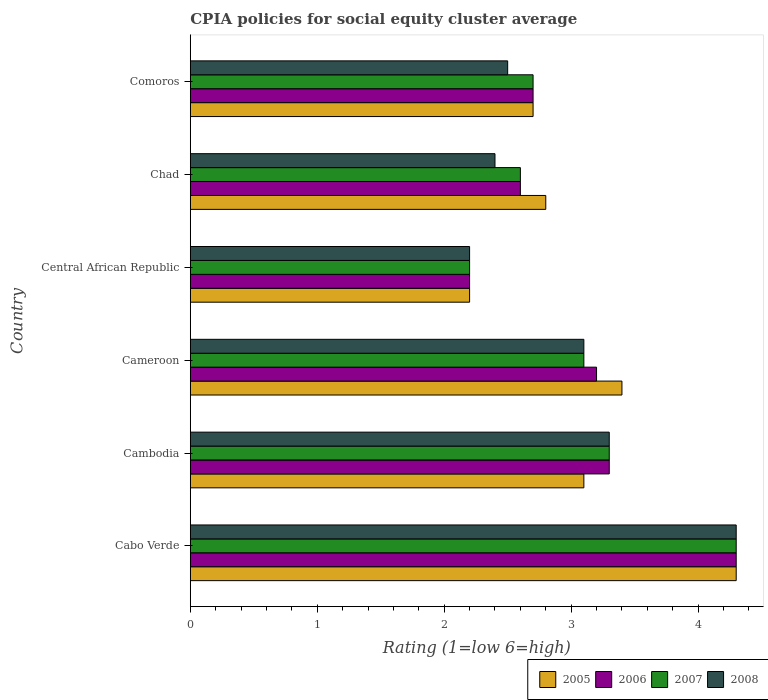Are the number of bars per tick equal to the number of legend labels?
Your response must be concise. Yes. How many bars are there on the 4th tick from the top?
Make the answer very short. 4. How many bars are there on the 3rd tick from the bottom?
Offer a very short reply. 4. What is the label of the 2nd group of bars from the top?
Ensure brevity in your answer.  Chad. Across all countries, what is the maximum CPIA rating in 2006?
Provide a short and direct response. 4.3. Across all countries, what is the minimum CPIA rating in 2008?
Make the answer very short. 2.2. In which country was the CPIA rating in 2008 maximum?
Provide a succinct answer. Cabo Verde. In which country was the CPIA rating in 2006 minimum?
Provide a succinct answer. Central African Republic. What is the difference between the CPIA rating in 2005 in Cambodia and that in Comoros?
Your answer should be very brief. 0.4. What is the difference between the CPIA rating in 2007 in Cambodia and the CPIA rating in 2005 in Central African Republic?
Make the answer very short. 1.1. What is the average CPIA rating in 2006 per country?
Your answer should be compact. 3.05. What is the ratio of the CPIA rating in 2008 in Cambodia to that in Comoros?
Provide a short and direct response. 1.32. Is the CPIA rating in 2005 in Cabo Verde less than that in Central African Republic?
Your answer should be very brief. No. Is the difference between the CPIA rating in 2008 in Cambodia and Central African Republic greater than the difference between the CPIA rating in 2007 in Cambodia and Central African Republic?
Your answer should be very brief. No. What is the difference between the highest and the second highest CPIA rating in 2005?
Make the answer very short. 0.9. What is the difference between the highest and the lowest CPIA rating in 2005?
Make the answer very short. 2.1. In how many countries, is the CPIA rating in 2008 greater than the average CPIA rating in 2008 taken over all countries?
Give a very brief answer. 3. Is the sum of the CPIA rating in 2007 in Central African Republic and Chad greater than the maximum CPIA rating in 2006 across all countries?
Your response must be concise. Yes. What does the 4th bar from the top in Cabo Verde represents?
Offer a very short reply. 2005. What does the 2nd bar from the bottom in Cambodia represents?
Provide a succinct answer. 2006. How many countries are there in the graph?
Make the answer very short. 6. Are the values on the major ticks of X-axis written in scientific E-notation?
Offer a very short reply. No. Does the graph contain any zero values?
Ensure brevity in your answer.  No. Does the graph contain grids?
Offer a very short reply. No. How many legend labels are there?
Ensure brevity in your answer.  4. How are the legend labels stacked?
Offer a very short reply. Horizontal. What is the title of the graph?
Your answer should be very brief. CPIA policies for social equity cluster average. What is the label or title of the X-axis?
Your answer should be very brief. Rating (1=low 6=high). What is the label or title of the Y-axis?
Your response must be concise. Country. What is the Rating (1=low 6=high) in 2005 in Cabo Verde?
Ensure brevity in your answer.  4.3. What is the Rating (1=low 6=high) of 2006 in Cabo Verde?
Give a very brief answer. 4.3. What is the Rating (1=low 6=high) in 2007 in Cambodia?
Provide a short and direct response. 3.3. What is the Rating (1=low 6=high) of 2008 in Cambodia?
Your answer should be very brief. 3.3. What is the Rating (1=low 6=high) of 2008 in Cameroon?
Your answer should be very brief. 3.1. What is the Rating (1=low 6=high) in 2008 in Central African Republic?
Ensure brevity in your answer.  2.2. What is the Rating (1=low 6=high) of 2005 in Chad?
Provide a succinct answer. 2.8. What is the Rating (1=low 6=high) of 2006 in Chad?
Your answer should be very brief. 2.6. What is the Rating (1=low 6=high) of 2007 in Chad?
Your answer should be compact. 2.6. What is the Rating (1=low 6=high) in 2008 in Chad?
Make the answer very short. 2.4. What is the Rating (1=low 6=high) of 2006 in Comoros?
Ensure brevity in your answer.  2.7. What is the Rating (1=low 6=high) in 2008 in Comoros?
Your answer should be very brief. 2.5. Across all countries, what is the maximum Rating (1=low 6=high) in 2006?
Make the answer very short. 4.3. Across all countries, what is the maximum Rating (1=low 6=high) in 2007?
Offer a very short reply. 4.3. Across all countries, what is the maximum Rating (1=low 6=high) in 2008?
Your answer should be very brief. 4.3. Across all countries, what is the minimum Rating (1=low 6=high) in 2006?
Your response must be concise. 2.2. Across all countries, what is the minimum Rating (1=low 6=high) in 2007?
Ensure brevity in your answer.  2.2. What is the total Rating (1=low 6=high) of 2005 in the graph?
Your response must be concise. 18.5. What is the difference between the Rating (1=low 6=high) of 2005 in Cabo Verde and that in Cambodia?
Provide a succinct answer. 1.2. What is the difference between the Rating (1=low 6=high) in 2006 in Cabo Verde and that in Cambodia?
Make the answer very short. 1. What is the difference between the Rating (1=low 6=high) in 2007 in Cabo Verde and that in Cambodia?
Your answer should be very brief. 1. What is the difference between the Rating (1=low 6=high) in 2007 in Cabo Verde and that in Cameroon?
Make the answer very short. 1.2. What is the difference between the Rating (1=low 6=high) in 2005 in Cabo Verde and that in Central African Republic?
Ensure brevity in your answer.  2.1. What is the difference between the Rating (1=low 6=high) of 2006 in Cabo Verde and that in Central African Republic?
Provide a succinct answer. 2.1. What is the difference between the Rating (1=low 6=high) of 2007 in Cabo Verde and that in Central African Republic?
Keep it short and to the point. 2.1. What is the difference between the Rating (1=low 6=high) of 2007 in Cabo Verde and that in Chad?
Offer a very short reply. 1.7. What is the difference between the Rating (1=low 6=high) of 2005 in Cabo Verde and that in Comoros?
Give a very brief answer. 1.6. What is the difference between the Rating (1=low 6=high) in 2007 in Cabo Verde and that in Comoros?
Provide a short and direct response. 1.6. What is the difference between the Rating (1=low 6=high) of 2008 in Cabo Verde and that in Comoros?
Ensure brevity in your answer.  1.8. What is the difference between the Rating (1=low 6=high) of 2006 in Cambodia and that in Cameroon?
Your answer should be compact. 0.1. What is the difference between the Rating (1=low 6=high) of 2006 in Cambodia and that in Central African Republic?
Provide a short and direct response. 1.1. What is the difference between the Rating (1=low 6=high) in 2007 in Cambodia and that in Central African Republic?
Keep it short and to the point. 1.1. What is the difference between the Rating (1=low 6=high) of 2008 in Cambodia and that in Central African Republic?
Your answer should be compact. 1.1. What is the difference between the Rating (1=low 6=high) in 2006 in Cambodia and that in Chad?
Offer a very short reply. 0.7. What is the difference between the Rating (1=low 6=high) in 2008 in Cambodia and that in Chad?
Give a very brief answer. 0.9. What is the difference between the Rating (1=low 6=high) in 2008 in Cambodia and that in Comoros?
Ensure brevity in your answer.  0.8. What is the difference between the Rating (1=low 6=high) of 2007 in Cameroon and that in Central African Republic?
Offer a very short reply. 0.9. What is the difference between the Rating (1=low 6=high) of 2006 in Cameroon and that in Chad?
Your response must be concise. 0.6. What is the difference between the Rating (1=low 6=high) in 2007 in Cameroon and that in Chad?
Your answer should be compact. 0.5. What is the difference between the Rating (1=low 6=high) in 2006 in Cameroon and that in Comoros?
Offer a very short reply. 0.5. What is the difference between the Rating (1=low 6=high) in 2008 in Cameroon and that in Comoros?
Offer a very short reply. 0.6. What is the difference between the Rating (1=low 6=high) of 2005 in Central African Republic and that in Comoros?
Provide a short and direct response. -0.5. What is the difference between the Rating (1=low 6=high) in 2006 in Central African Republic and that in Comoros?
Your response must be concise. -0.5. What is the difference between the Rating (1=low 6=high) of 2007 in Central African Republic and that in Comoros?
Offer a very short reply. -0.5. What is the difference between the Rating (1=low 6=high) in 2006 in Chad and that in Comoros?
Make the answer very short. -0.1. What is the difference between the Rating (1=low 6=high) of 2007 in Chad and that in Comoros?
Your answer should be very brief. -0.1. What is the difference between the Rating (1=low 6=high) in 2008 in Chad and that in Comoros?
Your answer should be compact. -0.1. What is the difference between the Rating (1=low 6=high) of 2005 in Cabo Verde and the Rating (1=low 6=high) of 2008 in Cambodia?
Ensure brevity in your answer.  1. What is the difference between the Rating (1=low 6=high) of 2006 in Cabo Verde and the Rating (1=low 6=high) of 2007 in Cambodia?
Offer a terse response. 1. What is the difference between the Rating (1=low 6=high) in 2007 in Cabo Verde and the Rating (1=low 6=high) in 2008 in Cambodia?
Ensure brevity in your answer.  1. What is the difference between the Rating (1=low 6=high) in 2005 in Cabo Verde and the Rating (1=low 6=high) in 2007 in Cameroon?
Make the answer very short. 1.2. What is the difference between the Rating (1=low 6=high) of 2005 in Cabo Verde and the Rating (1=low 6=high) of 2008 in Cameroon?
Provide a succinct answer. 1.2. What is the difference between the Rating (1=low 6=high) in 2005 in Cabo Verde and the Rating (1=low 6=high) in 2006 in Central African Republic?
Give a very brief answer. 2.1. What is the difference between the Rating (1=low 6=high) of 2005 in Cabo Verde and the Rating (1=low 6=high) of 2008 in Central African Republic?
Your response must be concise. 2.1. What is the difference between the Rating (1=low 6=high) of 2005 in Cabo Verde and the Rating (1=low 6=high) of 2007 in Chad?
Your answer should be compact. 1.7. What is the difference between the Rating (1=low 6=high) of 2005 in Cabo Verde and the Rating (1=low 6=high) of 2008 in Chad?
Keep it short and to the point. 1.9. What is the difference between the Rating (1=low 6=high) in 2005 in Cabo Verde and the Rating (1=low 6=high) in 2007 in Comoros?
Make the answer very short. 1.6. What is the difference between the Rating (1=low 6=high) of 2005 in Cabo Verde and the Rating (1=low 6=high) of 2008 in Comoros?
Offer a terse response. 1.8. What is the difference between the Rating (1=low 6=high) in 2006 in Cabo Verde and the Rating (1=low 6=high) in 2007 in Comoros?
Provide a short and direct response. 1.6. What is the difference between the Rating (1=low 6=high) in 2007 in Cabo Verde and the Rating (1=low 6=high) in 2008 in Comoros?
Keep it short and to the point. 1.8. What is the difference between the Rating (1=low 6=high) of 2005 in Cambodia and the Rating (1=low 6=high) of 2007 in Cameroon?
Your response must be concise. 0. What is the difference between the Rating (1=low 6=high) in 2005 in Cambodia and the Rating (1=low 6=high) in 2008 in Cameroon?
Give a very brief answer. 0. What is the difference between the Rating (1=low 6=high) of 2006 in Cambodia and the Rating (1=low 6=high) of 2008 in Cameroon?
Offer a very short reply. 0.2. What is the difference between the Rating (1=low 6=high) of 2007 in Cambodia and the Rating (1=low 6=high) of 2008 in Cameroon?
Provide a short and direct response. 0.2. What is the difference between the Rating (1=low 6=high) of 2005 in Cambodia and the Rating (1=low 6=high) of 2007 in Central African Republic?
Offer a terse response. 0.9. What is the difference between the Rating (1=low 6=high) of 2005 in Cambodia and the Rating (1=low 6=high) of 2008 in Central African Republic?
Give a very brief answer. 0.9. What is the difference between the Rating (1=low 6=high) of 2006 in Cambodia and the Rating (1=low 6=high) of 2007 in Central African Republic?
Your answer should be compact. 1.1. What is the difference between the Rating (1=low 6=high) of 2006 in Cambodia and the Rating (1=low 6=high) of 2008 in Central African Republic?
Your answer should be compact. 1.1. What is the difference between the Rating (1=low 6=high) in 2005 in Cambodia and the Rating (1=low 6=high) in 2006 in Chad?
Your answer should be very brief. 0.5. What is the difference between the Rating (1=low 6=high) of 2005 in Cambodia and the Rating (1=low 6=high) of 2007 in Chad?
Your answer should be very brief. 0.5. What is the difference between the Rating (1=low 6=high) in 2005 in Cambodia and the Rating (1=low 6=high) in 2008 in Chad?
Provide a short and direct response. 0.7. What is the difference between the Rating (1=low 6=high) of 2006 in Cambodia and the Rating (1=low 6=high) of 2008 in Chad?
Offer a very short reply. 0.9. What is the difference between the Rating (1=low 6=high) in 2007 in Cambodia and the Rating (1=low 6=high) in 2008 in Chad?
Give a very brief answer. 0.9. What is the difference between the Rating (1=low 6=high) of 2007 in Cambodia and the Rating (1=low 6=high) of 2008 in Comoros?
Make the answer very short. 0.8. What is the difference between the Rating (1=low 6=high) in 2006 in Cameroon and the Rating (1=low 6=high) in 2008 in Central African Republic?
Provide a short and direct response. 1. What is the difference between the Rating (1=low 6=high) in 2005 in Cameroon and the Rating (1=low 6=high) in 2006 in Chad?
Offer a terse response. 0.8. What is the difference between the Rating (1=low 6=high) in 2006 in Cameroon and the Rating (1=low 6=high) in 2007 in Chad?
Offer a terse response. 0.6. What is the difference between the Rating (1=low 6=high) of 2006 in Cameroon and the Rating (1=low 6=high) of 2008 in Chad?
Offer a terse response. 0.8. What is the difference between the Rating (1=low 6=high) of 2007 in Cameroon and the Rating (1=low 6=high) of 2008 in Chad?
Offer a very short reply. 0.7. What is the difference between the Rating (1=low 6=high) in 2005 in Cameroon and the Rating (1=low 6=high) in 2006 in Comoros?
Give a very brief answer. 0.7. What is the difference between the Rating (1=low 6=high) of 2005 in Cameroon and the Rating (1=low 6=high) of 2007 in Comoros?
Provide a short and direct response. 0.7. What is the difference between the Rating (1=low 6=high) in 2005 in Cameroon and the Rating (1=low 6=high) in 2008 in Comoros?
Offer a terse response. 0.9. What is the difference between the Rating (1=low 6=high) of 2006 in Cameroon and the Rating (1=low 6=high) of 2007 in Comoros?
Offer a very short reply. 0.5. What is the difference between the Rating (1=low 6=high) of 2005 in Central African Republic and the Rating (1=low 6=high) of 2006 in Chad?
Provide a succinct answer. -0.4. What is the difference between the Rating (1=low 6=high) of 2006 in Central African Republic and the Rating (1=low 6=high) of 2007 in Chad?
Make the answer very short. -0.4. What is the difference between the Rating (1=low 6=high) in 2006 in Central African Republic and the Rating (1=low 6=high) in 2008 in Chad?
Your response must be concise. -0.2. What is the difference between the Rating (1=low 6=high) in 2005 in Central African Republic and the Rating (1=low 6=high) in 2006 in Comoros?
Offer a terse response. -0.5. What is the difference between the Rating (1=low 6=high) in 2005 in Central African Republic and the Rating (1=low 6=high) in 2007 in Comoros?
Keep it short and to the point. -0.5. What is the difference between the Rating (1=low 6=high) in 2006 in Central African Republic and the Rating (1=low 6=high) in 2008 in Comoros?
Provide a short and direct response. -0.3. What is the difference between the Rating (1=low 6=high) of 2007 in Central African Republic and the Rating (1=low 6=high) of 2008 in Comoros?
Ensure brevity in your answer.  -0.3. What is the difference between the Rating (1=low 6=high) of 2005 in Chad and the Rating (1=low 6=high) of 2006 in Comoros?
Keep it short and to the point. 0.1. What is the difference between the Rating (1=low 6=high) of 2005 in Chad and the Rating (1=low 6=high) of 2007 in Comoros?
Your response must be concise. 0.1. What is the difference between the Rating (1=low 6=high) in 2006 in Chad and the Rating (1=low 6=high) in 2008 in Comoros?
Provide a succinct answer. 0.1. What is the difference between the Rating (1=low 6=high) in 2007 in Chad and the Rating (1=low 6=high) in 2008 in Comoros?
Your response must be concise. 0.1. What is the average Rating (1=low 6=high) of 2005 per country?
Offer a very short reply. 3.08. What is the average Rating (1=low 6=high) of 2006 per country?
Your answer should be very brief. 3.05. What is the average Rating (1=low 6=high) of 2007 per country?
Make the answer very short. 3.03. What is the average Rating (1=low 6=high) of 2008 per country?
Provide a succinct answer. 2.97. What is the difference between the Rating (1=low 6=high) in 2005 and Rating (1=low 6=high) in 2007 in Cabo Verde?
Your answer should be compact. 0. What is the difference between the Rating (1=low 6=high) in 2005 and Rating (1=low 6=high) in 2008 in Cabo Verde?
Your answer should be very brief. 0. What is the difference between the Rating (1=low 6=high) in 2007 and Rating (1=low 6=high) in 2008 in Cabo Verde?
Provide a succinct answer. 0. What is the difference between the Rating (1=low 6=high) of 2005 and Rating (1=low 6=high) of 2006 in Cambodia?
Make the answer very short. -0.2. What is the difference between the Rating (1=low 6=high) of 2006 and Rating (1=low 6=high) of 2007 in Cambodia?
Your answer should be very brief. 0. What is the difference between the Rating (1=low 6=high) in 2006 and Rating (1=low 6=high) in 2008 in Cambodia?
Ensure brevity in your answer.  0. What is the difference between the Rating (1=low 6=high) in 2005 and Rating (1=low 6=high) in 2006 in Cameroon?
Provide a short and direct response. 0.2. What is the difference between the Rating (1=low 6=high) of 2005 and Rating (1=low 6=high) of 2008 in Cameroon?
Keep it short and to the point. 0.3. What is the difference between the Rating (1=low 6=high) of 2006 and Rating (1=low 6=high) of 2007 in Cameroon?
Provide a short and direct response. 0.1. What is the difference between the Rating (1=low 6=high) in 2006 and Rating (1=low 6=high) in 2008 in Cameroon?
Offer a terse response. 0.1. What is the difference between the Rating (1=low 6=high) in 2007 and Rating (1=low 6=high) in 2008 in Cameroon?
Give a very brief answer. 0. What is the difference between the Rating (1=low 6=high) in 2005 and Rating (1=low 6=high) in 2007 in Central African Republic?
Offer a very short reply. 0. What is the difference between the Rating (1=low 6=high) in 2005 and Rating (1=low 6=high) in 2008 in Central African Republic?
Offer a very short reply. 0. What is the difference between the Rating (1=low 6=high) in 2006 and Rating (1=low 6=high) in 2007 in Central African Republic?
Offer a very short reply. 0. What is the difference between the Rating (1=low 6=high) of 2007 and Rating (1=low 6=high) of 2008 in Central African Republic?
Keep it short and to the point. 0. What is the difference between the Rating (1=low 6=high) in 2005 and Rating (1=low 6=high) in 2006 in Chad?
Give a very brief answer. 0.2. What is the difference between the Rating (1=low 6=high) of 2006 and Rating (1=low 6=high) of 2007 in Chad?
Offer a very short reply. 0. What is the difference between the Rating (1=low 6=high) of 2007 and Rating (1=low 6=high) of 2008 in Chad?
Keep it short and to the point. 0.2. What is the difference between the Rating (1=low 6=high) of 2005 and Rating (1=low 6=high) of 2007 in Comoros?
Your answer should be very brief. 0. What is the difference between the Rating (1=low 6=high) of 2006 and Rating (1=low 6=high) of 2008 in Comoros?
Make the answer very short. 0.2. What is the difference between the Rating (1=low 6=high) of 2007 and Rating (1=low 6=high) of 2008 in Comoros?
Ensure brevity in your answer.  0.2. What is the ratio of the Rating (1=low 6=high) of 2005 in Cabo Verde to that in Cambodia?
Make the answer very short. 1.39. What is the ratio of the Rating (1=low 6=high) in 2006 in Cabo Verde to that in Cambodia?
Your response must be concise. 1.3. What is the ratio of the Rating (1=low 6=high) of 2007 in Cabo Verde to that in Cambodia?
Offer a terse response. 1.3. What is the ratio of the Rating (1=low 6=high) of 2008 in Cabo Verde to that in Cambodia?
Ensure brevity in your answer.  1.3. What is the ratio of the Rating (1=low 6=high) of 2005 in Cabo Verde to that in Cameroon?
Give a very brief answer. 1.26. What is the ratio of the Rating (1=low 6=high) in 2006 in Cabo Verde to that in Cameroon?
Provide a succinct answer. 1.34. What is the ratio of the Rating (1=low 6=high) of 2007 in Cabo Verde to that in Cameroon?
Provide a succinct answer. 1.39. What is the ratio of the Rating (1=low 6=high) in 2008 in Cabo Verde to that in Cameroon?
Ensure brevity in your answer.  1.39. What is the ratio of the Rating (1=low 6=high) of 2005 in Cabo Verde to that in Central African Republic?
Make the answer very short. 1.95. What is the ratio of the Rating (1=low 6=high) of 2006 in Cabo Verde to that in Central African Republic?
Keep it short and to the point. 1.95. What is the ratio of the Rating (1=low 6=high) of 2007 in Cabo Verde to that in Central African Republic?
Provide a succinct answer. 1.95. What is the ratio of the Rating (1=low 6=high) in 2008 in Cabo Verde to that in Central African Republic?
Your answer should be compact. 1.95. What is the ratio of the Rating (1=low 6=high) in 2005 in Cabo Verde to that in Chad?
Keep it short and to the point. 1.54. What is the ratio of the Rating (1=low 6=high) of 2006 in Cabo Verde to that in Chad?
Your answer should be very brief. 1.65. What is the ratio of the Rating (1=low 6=high) in 2007 in Cabo Verde to that in Chad?
Keep it short and to the point. 1.65. What is the ratio of the Rating (1=low 6=high) in 2008 in Cabo Verde to that in Chad?
Your answer should be very brief. 1.79. What is the ratio of the Rating (1=low 6=high) of 2005 in Cabo Verde to that in Comoros?
Give a very brief answer. 1.59. What is the ratio of the Rating (1=low 6=high) in 2006 in Cabo Verde to that in Comoros?
Ensure brevity in your answer.  1.59. What is the ratio of the Rating (1=low 6=high) of 2007 in Cabo Verde to that in Comoros?
Ensure brevity in your answer.  1.59. What is the ratio of the Rating (1=low 6=high) in 2008 in Cabo Verde to that in Comoros?
Ensure brevity in your answer.  1.72. What is the ratio of the Rating (1=low 6=high) in 2005 in Cambodia to that in Cameroon?
Your answer should be very brief. 0.91. What is the ratio of the Rating (1=low 6=high) of 2006 in Cambodia to that in Cameroon?
Offer a terse response. 1.03. What is the ratio of the Rating (1=low 6=high) in 2007 in Cambodia to that in Cameroon?
Give a very brief answer. 1.06. What is the ratio of the Rating (1=low 6=high) of 2008 in Cambodia to that in Cameroon?
Make the answer very short. 1.06. What is the ratio of the Rating (1=low 6=high) of 2005 in Cambodia to that in Central African Republic?
Offer a very short reply. 1.41. What is the ratio of the Rating (1=low 6=high) in 2005 in Cambodia to that in Chad?
Offer a terse response. 1.11. What is the ratio of the Rating (1=low 6=high) of 2006 in Cambodia to that in Chad?
Make the answer very short. 1.27. What is the ratio of the Rating (1=low 6=high) in 2007 in Cambodia to that in Chad?
Your response must be concise. 1.27. What is the ratio of the Rating (1=low 6=high) of 2008 in Cambodia to that in Chad?
Make the answer very short. 1.38. What is the ratio of the Rating (1=low 6=high) of 2005 in Cambodia to that in Comoros?
Your answer should be very brief. 1.15. What is the ratio of the Rating (1=low 6=high) in 2006 in Cambodia to that in Comoros?
Your answer should be compact. 1.22. What is the ratio of the Rating (1=low 6=high) of 2007 in Cambodia to that in Comoros?
Keep it short and to the point. 1.22. What is the ratio of the Rating (1=low 6=high) in 2008 in Cambodia to that in Comoros?
Provide a short and direct response. 1.32. What is the ratio of the Rating (1=low 6=high) in 2005 in Cameroon to that in Central African Republic?
Offer a terse response. 1.55. What is the ratio of the Rating (1=low 6=high) of 2006 in Cameroon to that in Central African Republic?
Provide a succinct answer. 1.45. What is the ratio of the Rating (1=low 6=high) in 2007 in Cameroon to that in Central African Republic?
Provide a succinct answer. 1.41. What is the ratio of the Rating (1=low 6=high) of 2008 in Cameroon to that in Central African Republic?
Keep it short and to the point. 1.41. What is the ratio of the Rating (1=low 6=high) of 2005 in Cameroon to that in Chad?
Your response must be concise. 1.21. What is the ratio of the Rating (1=low 6=high) in 2006 in Cameroon to that in Chad?
Give a very brief answer. 1.23. What is the ratio of the Rating (1=low 6=high) of 2007 in Cameroon to that in Chad?
Offer a very short reply. 1.19. What is the ratio of the Rating (1=low 6=high) in 2008 in Cameroon to that in Chad?
Offer a terse response. 1.29. What is the ratio of the Rating (1=low 6=high) of 2005 in Cameroon to that in Comoros?
Ensure brevity in your answer.  1.26. What is the ratio of the Rating (1=low 6=high) of 2006 in Cameroon to that in Comoros?
Your answer should be very brief. 1.19. What is the ratio of the Rating (1=low 6=high) of 2007 in Cameroon to that in Comoros?
Keep it short and to the point. 1.15. What is the ratio of the Rating (1=low 6=high) of 2008 in Cameroon to that in Comoros?
Your response must be concise. 1.24. What is the ratio of the Rating (1=low 6=high) of 2005 in Central African Republic to that in Chad?
Make the answer very short. 0.79. What is the ratio of the Rating (1=low 6=high) of 2006 in Central African Republic to that in Chad?
Provide a succinct answer. 0.85. What is the ratio of the Rating (1=low 6=high) of 2007 in Central African Republic to that in Chad?
Your response must be concise. 0.85. What is the ratio of the Rating (1=low 6=high) in 2005 in Central African Republic to that in Comoros?
Offer a terse response. 0.81. What is the ratio of the Rating (1=low 6=high) of 2006 in Central African Republic to that in Comoros?
Keep it short and to the point. 0.81. What is the ratio of the Rating (1=low 6=high) in 2007 in Central African Republic to that in Comoros?
Your answer should be very brief. 0.81. What is the ratio of the Rating (1=low 6=high) of 2008 in Central African Republic to that in Comoros?
Offer a very short reply. 0.88. What is the ratio of the Rating (1=low 6=high) in 2005 in Chad to that in Comoros?
Your answer should be compact. 1.04. What is the ratio of the Rating (1=low 6=high) in 2008 in Chad to that in Comoros?
Make the answer very short. 0.96. What is the difference between the highest and the second highest Rating (1=low 6=high) of 2006?
Provide a succinct answer. 1. What is the difference between the highest and the second highest Rating (1=low 6=high) of 2008?
Give a very brief answer. 1. What is the difference between the highest and the lowest Rating (1=low 6=high) of 2006?
Provide a short and direct response. 2.1. What is the difference between the highest and the lowest Rating (1=low 6=high) in 2007?
Give a very brief answer. 2.1. What is the difference between the highest and the lowest Rating (1=low 6=high) in 2008?
Make the answer very short. 2.1. 